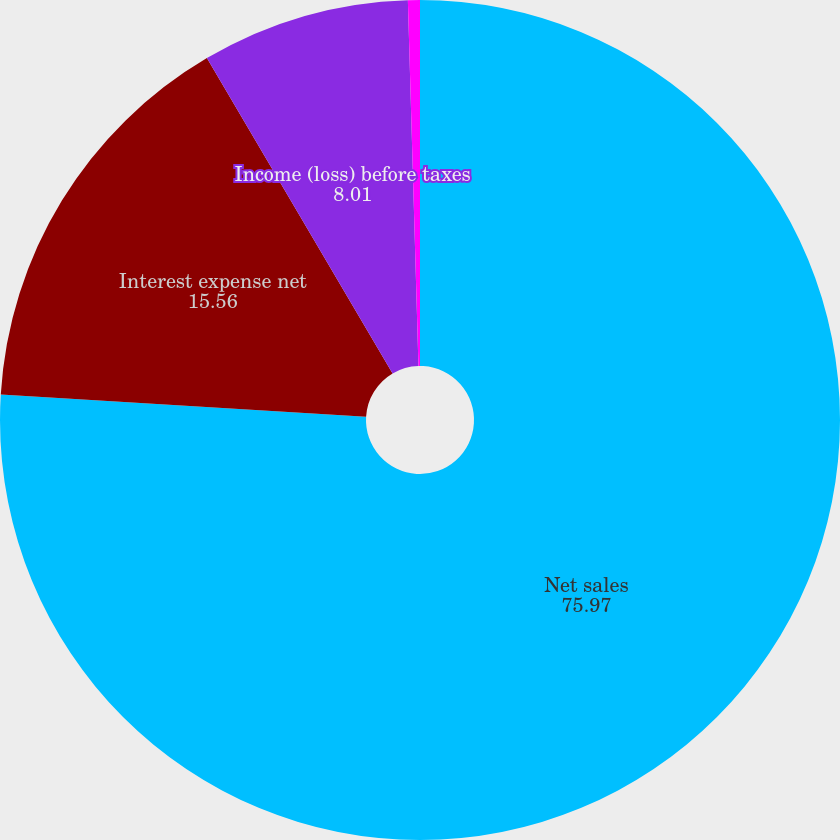<chart> <loc_0><loc_0><loc_500><loc_500><pie_chart><fcel>Net sales<fcel>Interest expense net<fcel>Income (loss) before taxes<fcel>(Provision) benefit for income<nl><fcel>75.97%<fcel>15.56%<fcel>8.01%<fcel>0.46%<nl></chart> 